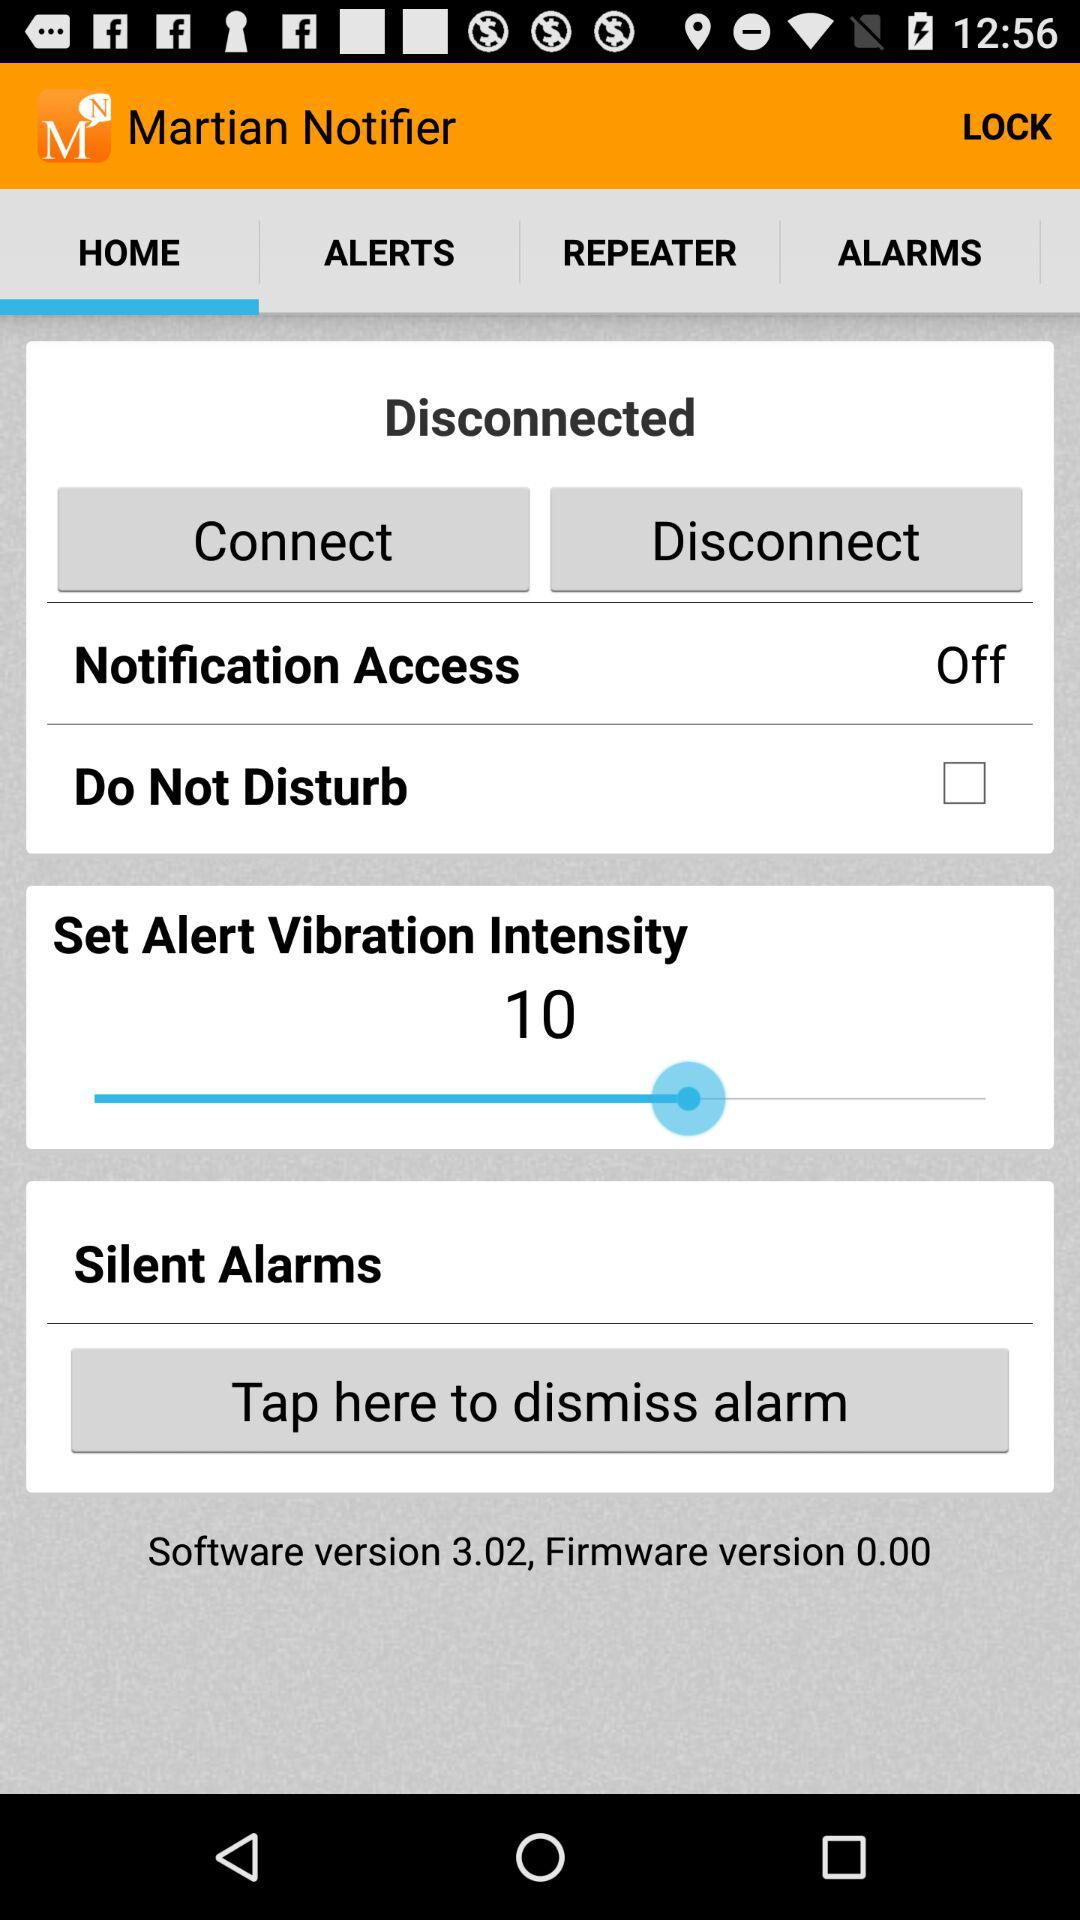What is the status of notification access? The status is off. 